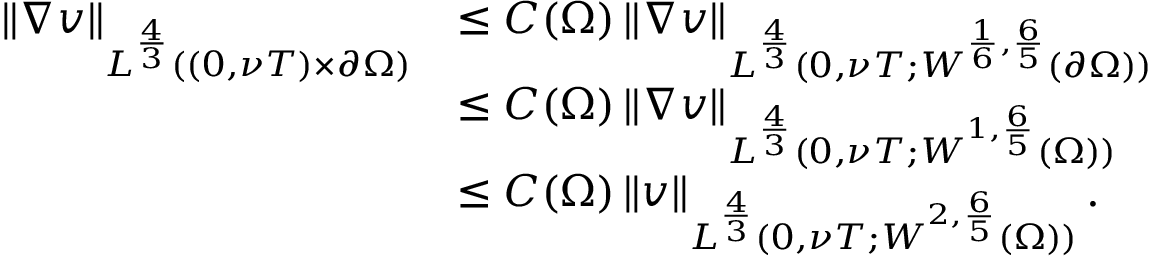Convert formula to latex. <formula><loc_0><loc_0><loc_500><loc_500>\begin{array} { r l } { \left \| \nabla v \right \| _ { L ^ { \frac { 4 } { 3 } } ( ( 0 , \nu T ) \times \partial \Omega ) } } & { \leq C ( \Omega ) \left \| \nabla v \right \| _ { L ^ { \frac { 4 } { 3 } } ( 0 , \nu T ; W ^ { \frac { 1 } { 6 } , \frac { 6 } { 5 } } ( \partial \Omega ) ) } } \\ & { \leq C ( \Omega ) \left \| \nabla v \right \| _ { L ^ { \frac { 4 } { 3 } } ( 0 , \nu T ; W ^ { 1 , \frac { 6 } { 5 } } ( \Omega ) ) } } \\ & { \leq C ( \Omega ) \left \| v \right \| _ { L ^ { \frac { 4 } { 3 } } ( 0 , \nu T ; W ^ { 2 , \frac { 6 } { 5 } } ( \Omega ) ) } . } \end{array}</formula> 